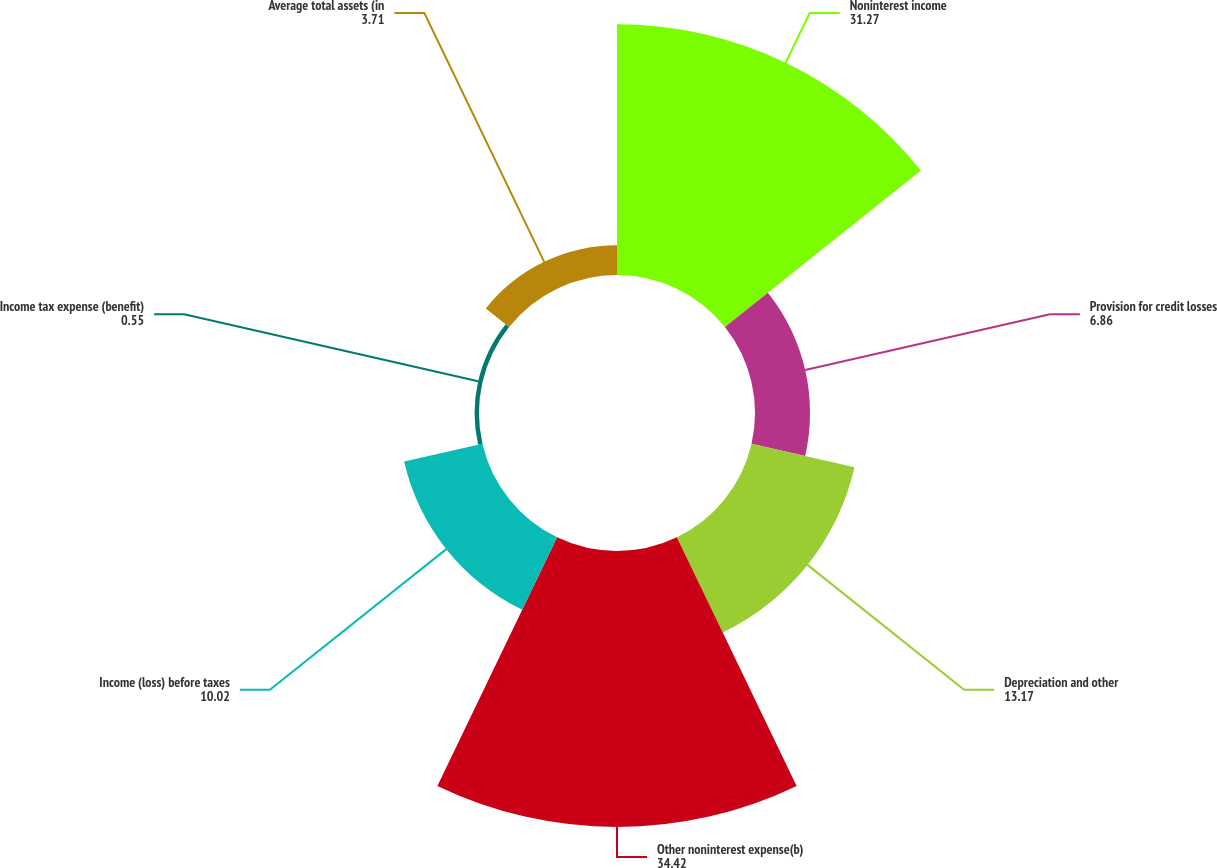<chart> <loc_0><loc_0><loc_500><loc_500><pie_chart><fcel>Noninterest income<fcel>Provision for credit losses<fcel>Depreciation and other<fcel>Other noninterest expense(b)<fcel>Income (loss) before taxes<fcel>Income tax expense (benefit)<fcel>Average total assets (in<nl><fcel>31.27%<fcel>6.86%<fcel>13.17%<fcel>34.42%<fcel>10.02%<fcel>0.55%<fcel>3.71%<nl></chart> 